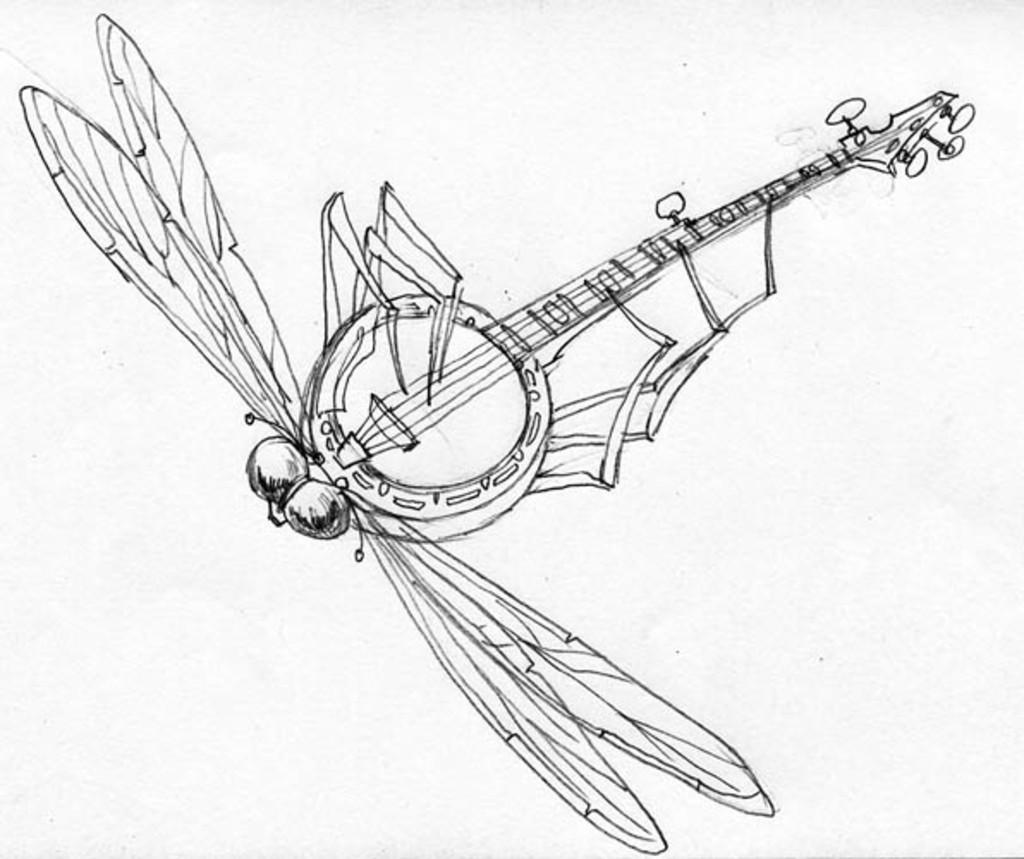What type of artwork is depicted in the image? There is a pencil sketch in the image. What objects or subjects are included in the sketch? The sketch contains a fly and a guitar. What type of tax is being discussed in the image? There is no discussion of tax in the image; it features a pencil sketch of a fly and a guitar. What type of glove is being worn by the guitarist in the image? There is no guitarist or glove present in the image; it only contains a sketch of a fly and a guitar. 